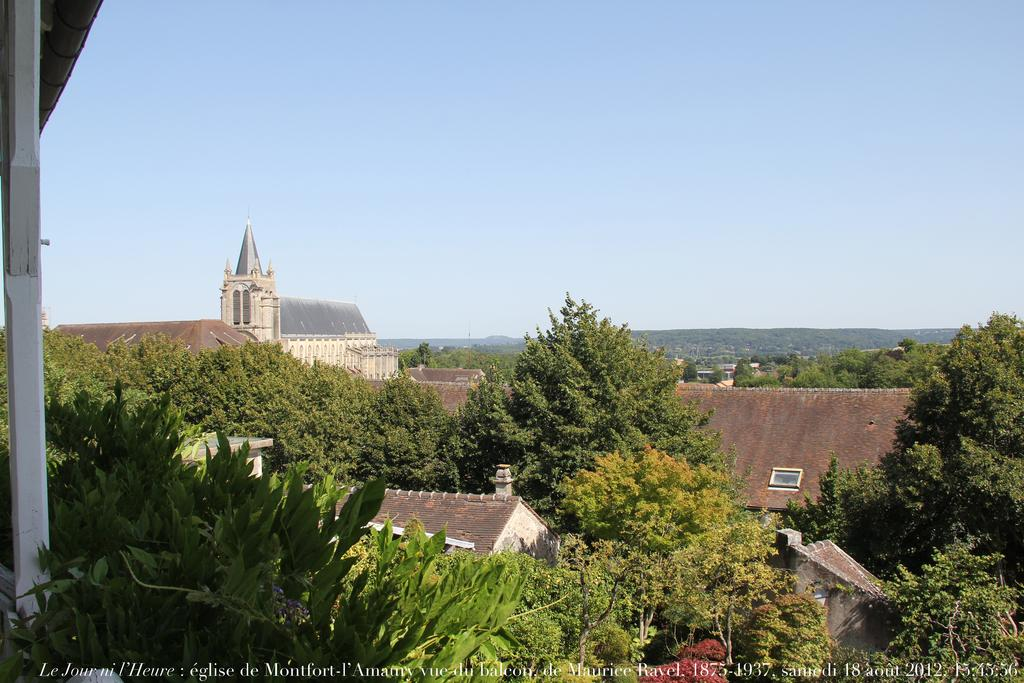What type of vegetation is visible in the image? There are trees in the image. What type of structures can be seen in the image? There are buildings in the image. What type of natural landform is present in the image? There are hills in the image. What is visible at the top of the image? The sky is visible at the top of the image. What type of cork can be seen on the tree in the image? There is no cork present on any of the trees in the image. How many hands are visible in the image? There are no hands visible in the image. 